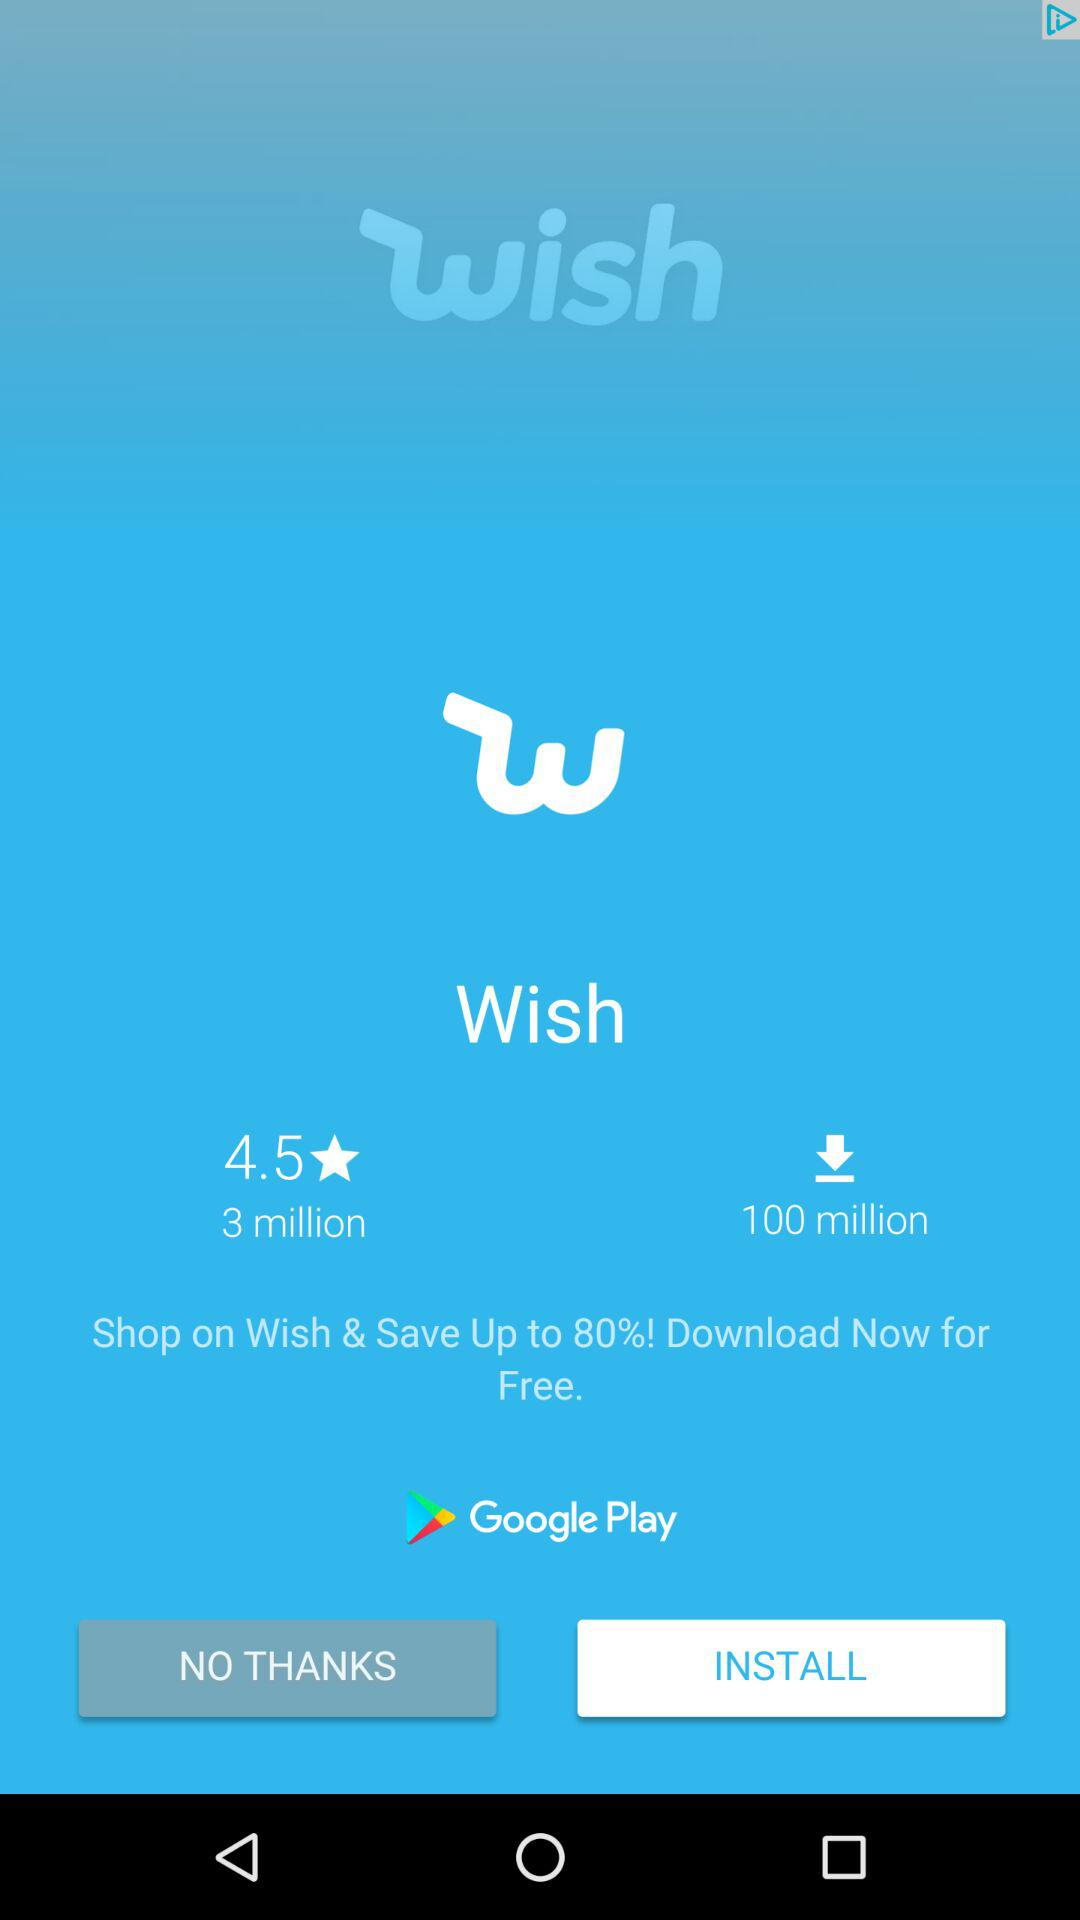How many more downloads does Wish have than reviews?
Answer the question using a single word or phrase. 97 million 